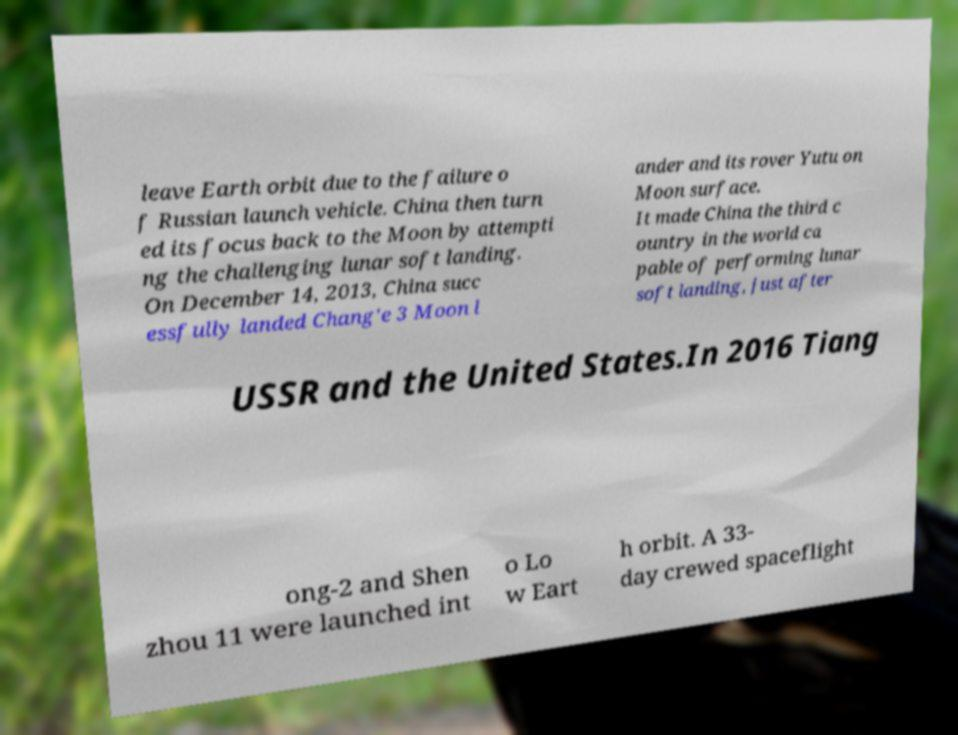There's text embedded in this image that I need extracted. Can you transcribe it verbatim? leave Earth orbit due to the failure o f Russian launch vehicle. China then turn ed its focus back to the Moon by attempti ng the challenging lunar soft landing. On December 14, 2013, China succ essfully landed Chang'e 3 Moon l ander and its rover Yutu on Moon surface. It made China the third c ountry in the world ca pable of performing lunar soft landing, just after USSR and the United States.In 2016 Tiang ong-2 and Shen zhou 11 were launched int o Lo w Eart h orbit. A 33- day crewed spaceflight 